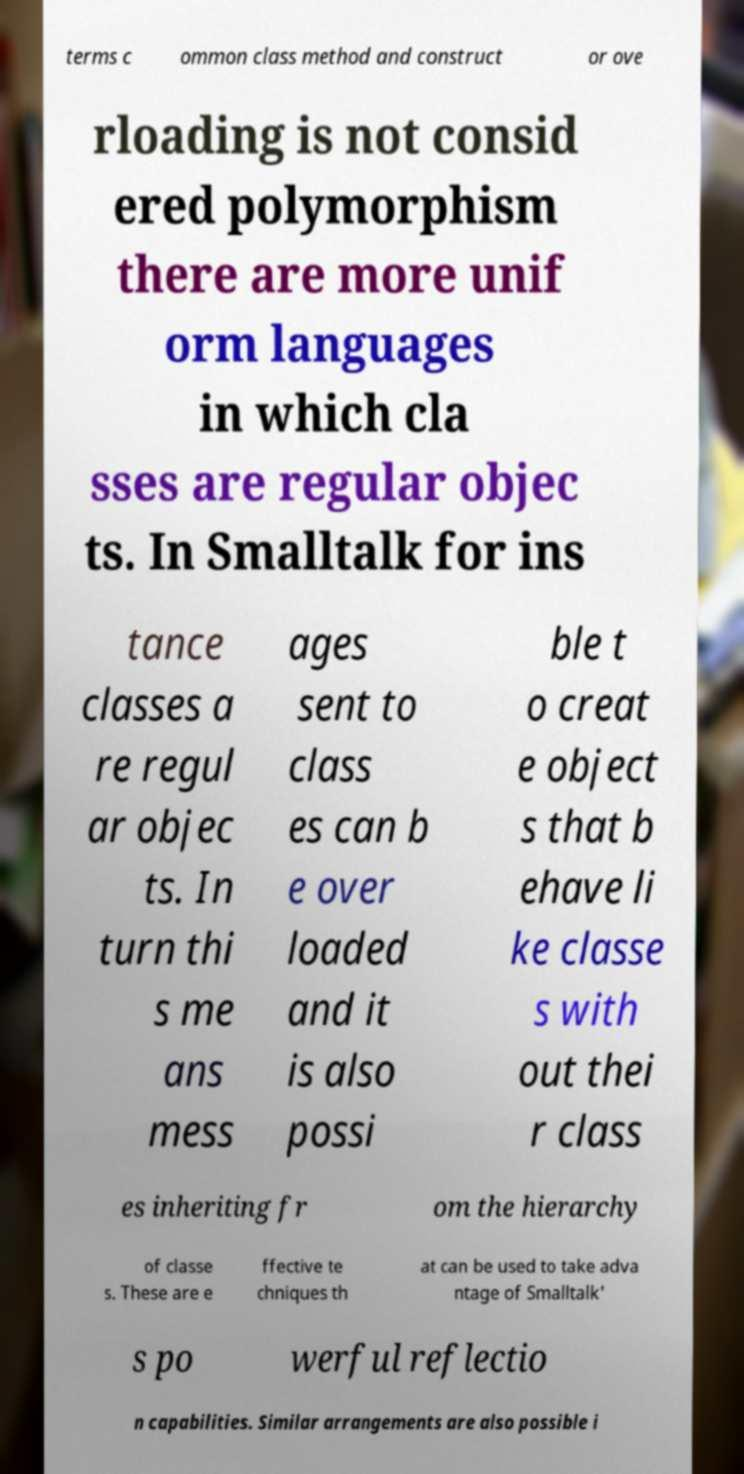Can you read and provide the text displayed in the image?This photo seems to have some interesting text. Can you extract and type it out for me? terms c ommon class method and construct or ove rloading is not consid ered polymorphism there are more unif orm languages in which cla sses are regular objec ts. In Smalltalk for ins tance classes a re regul ar objec ts. In turn thi s me ans mess ages sent to class es can b e over loaded and it is also possi ble t o creat e object s that b ehave li ke classe s with out thei r class es inheriting fr om the hierarchy of classe s. These are e ffective te chniques th at can be used to take adva ntage of Smalltalk' s po werful reflectio n capabilities. Similar arrangements are also possible i 